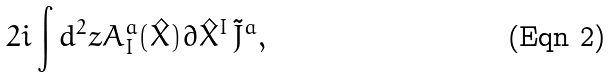<formula> <loc_0><loc_0><loc_500><loc_500>2 i \int { d ^ { 2 } z A _ { I } ^ { a } ( \hat { X } ) \partial \hat { X } ^ { I } \, \tilde { J } ^ { a } } ,</formula> 